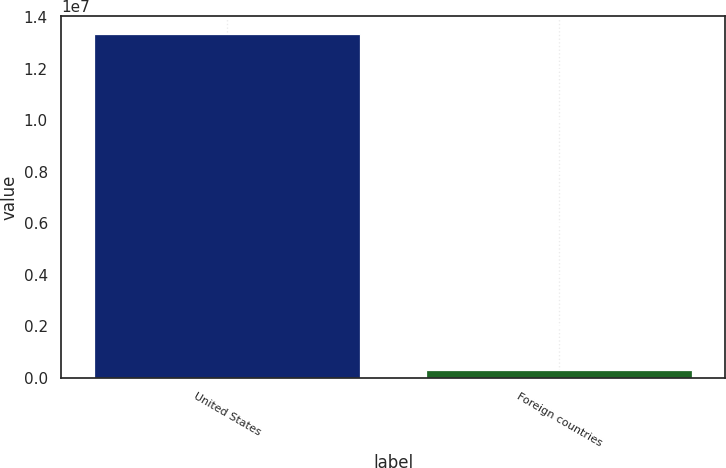Convert chart. <chart><loc_0><loc_0><loc_500><loc_500><bar_chart><fcel>United States<fcel>Foreign countries<nl><fcel>1.3365e+07<fcel>314787<nl></chart> 